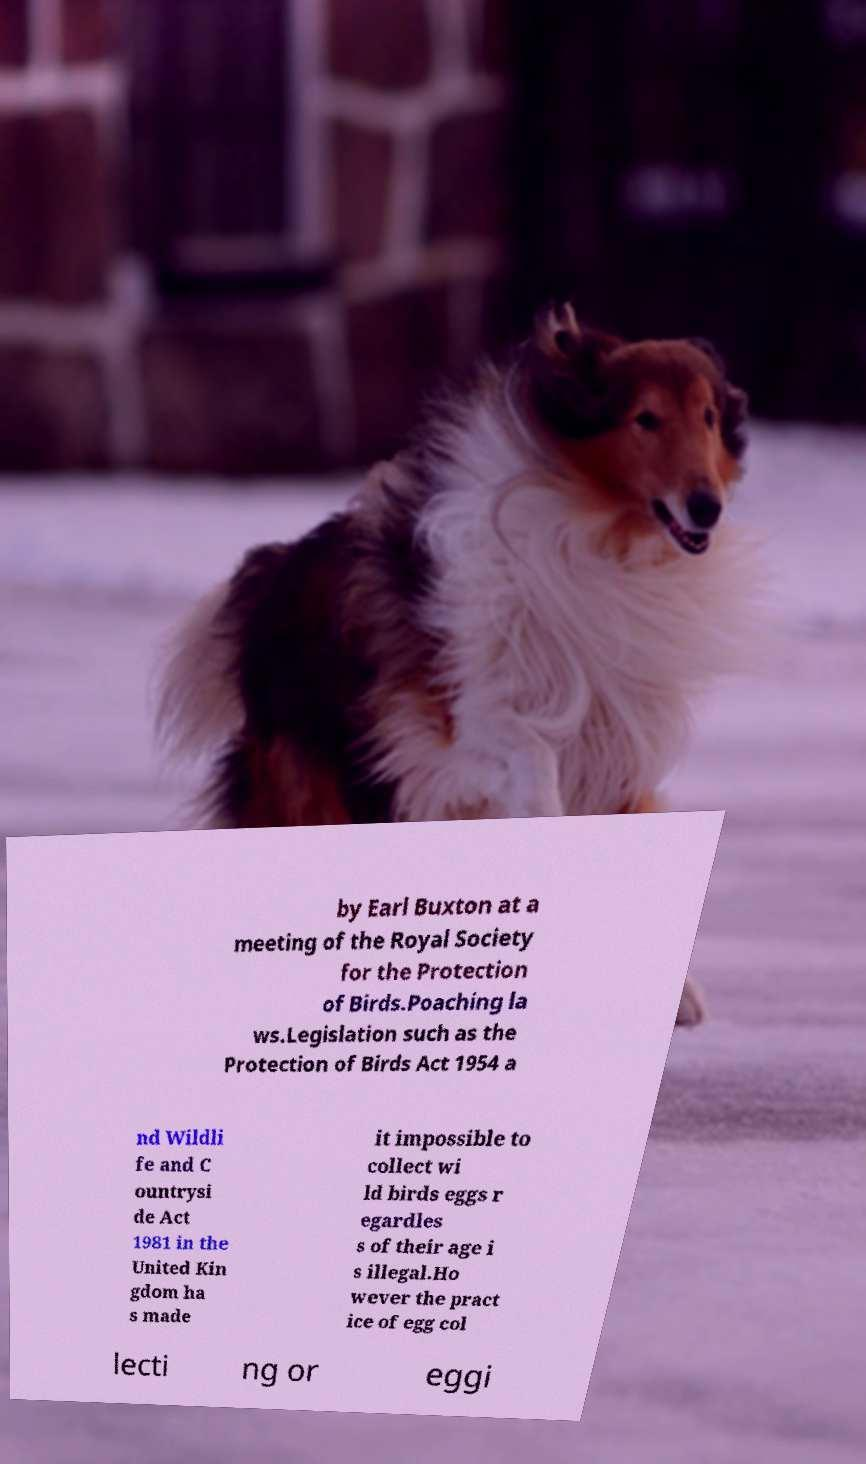Could you assist in decoding the text presented in this image and type it out clearly? by Earl Buxton at a meeting of the Royal Society for the Protection of Birds.Poaching la ws.Legislation such as the Protection of Birds Act 1954 a nd Wildli fe and C ountrysi de Act 1981 in the United Kin gdom ha s made it impossible to collect wi ld birds eggs r egardles s of their age i s illegal.Ho wever the pract ice of egg col lecti ng or eggi 